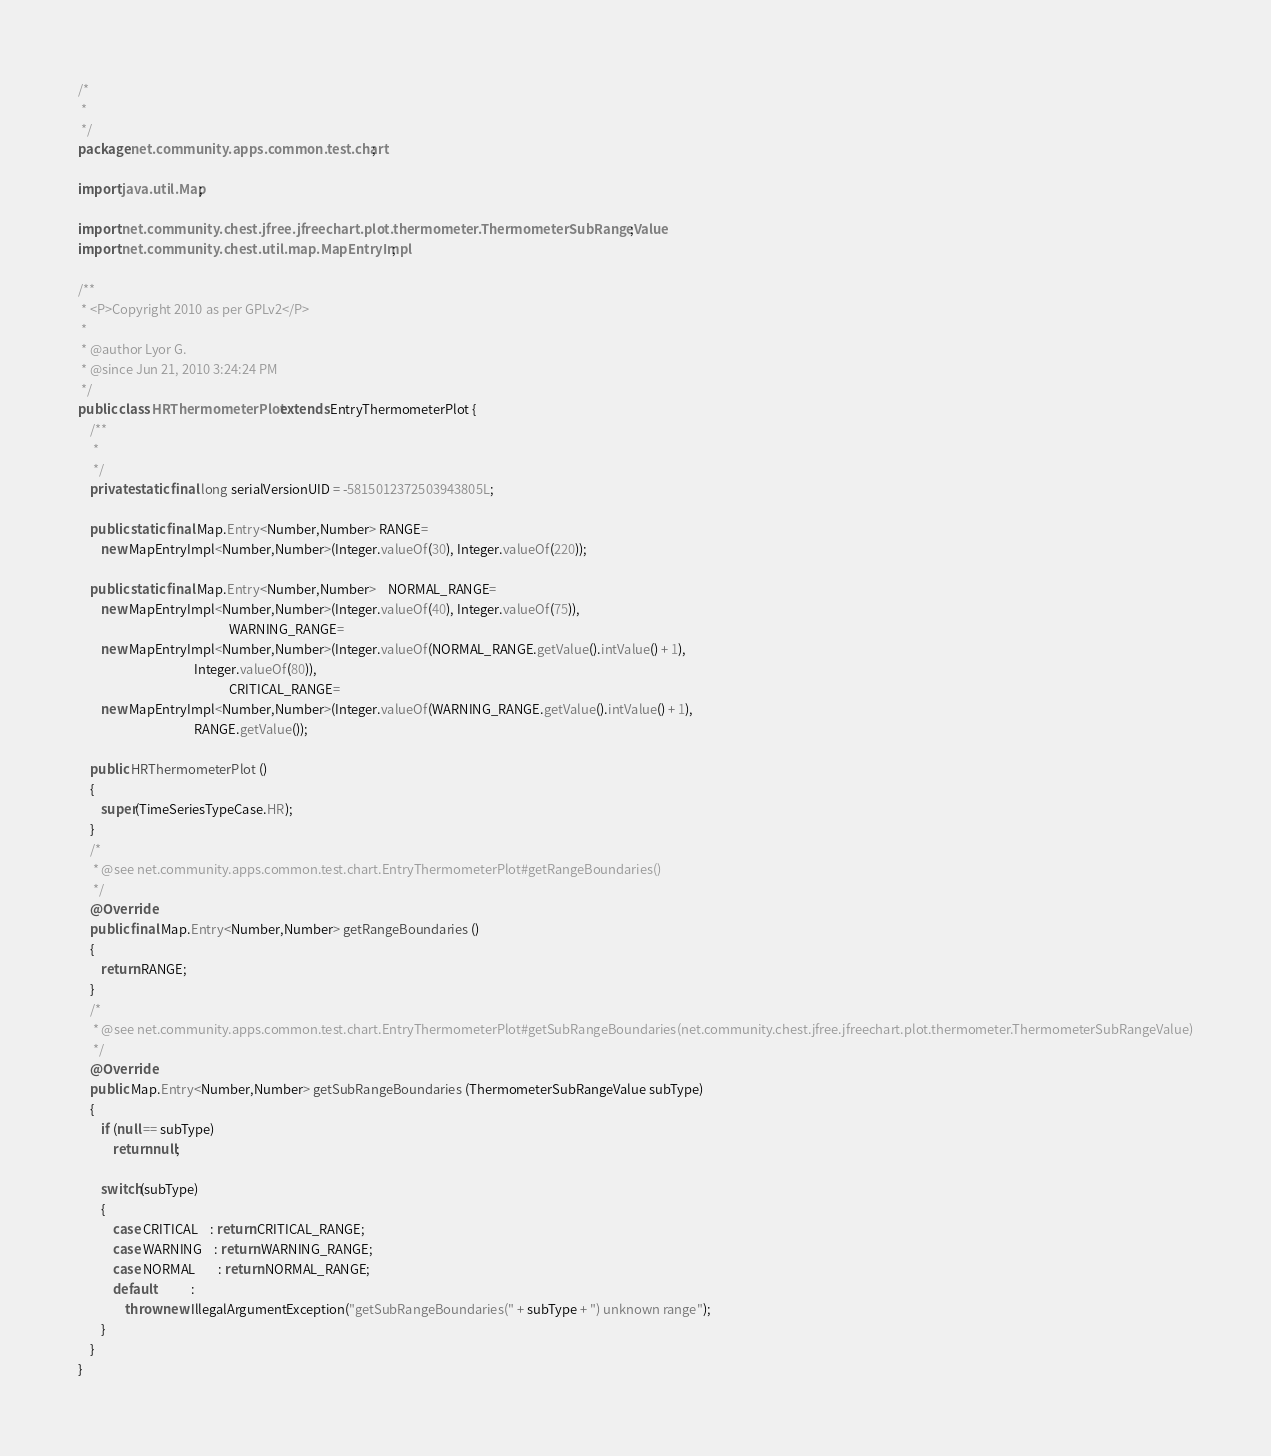Convert code to text. <code><loc_0><loc_0><loc_500><loc_500><_Java_>/*
 *
 */
package net.community.apps.common.test.chart;

import java.util.Map;

import net.community.chest.jfree.jfreechart.plot.thermometer.ThermometerSubRangeValue;
import net.community.chest.util.map.MapEntryImpl;

/**
 * <P>Copyright 2010 as per GPLv2</P>
 *
 * @author Lyor G.
 * @since Jun 21, 2010 3:24:24 PM
 */
public class HRThermometerPlot extends EntryThermometerPlot {
    /**
     *
     */
    private static final long serialVersionUID = -5815012372503943805L;

    public static final Map.Entry<Number,Number> RANGE=
        new MapEntryImpl<Number,Number>(Integer.valueOf(30), Integer.valueOf(220));

    public static final Map.Entry<Number,Number>    NORMAL_RANGE=
        new MapEntryImpl<Number,Number>(Integer.valueOf(40), Integer.valueOf(75)),
                                                    WARNING_RANGE=
        new MapEntryImpl<Number,Number>(Integer.valueOf(NORMAL_RANGE.getValue().intValue() + 1),
                                        Integer.valueOf(80)),
                                                    CRITICAL_RANGE=
        new MapEntryImpl<Number,Number>(Integer.valueOf(WARNING_RANGE.getValue().intValue() + 1),
                                        RANGE.getValue());

    public HRThermometerPlot ()
    {
        super(TimeSeriesTypeCase.HR);
    }
    /*
     * @see net.community.apps.common.test.chart.EntryThermometerPlot#getRangeBoundaries()
     */
    @Override
    public final Map.Entry<Number,Number> getRangeBoundaries ()
    {
        return RANGE;
    }
    /*
     * @see net.community.apps.common.test.chart.EntryThermometerPlot#getSubRangeBoundaries(net.community.chest.jfree.jfreechart.plot.thermometer.ThermometerSubRangeValue)
     */
    @Override
    public Map.Entry<Number,Number> getSubRangeBoundaries (ThermometerSubRangeValue subType)
    {
        if (null == subType)
            return null;

        switch(subType)
        {
            case CRITICAL    : return CRITICAL_RANGE;
            case WARNING    : return WARNING_RANGE;
            case NORMAL        : return NORMAL_RANGE;
            default            :
                throw new IllegalArgumentException("getSubRangeBoundaries(" + subType + ") unknown range");
        }
    }
}
</code> 